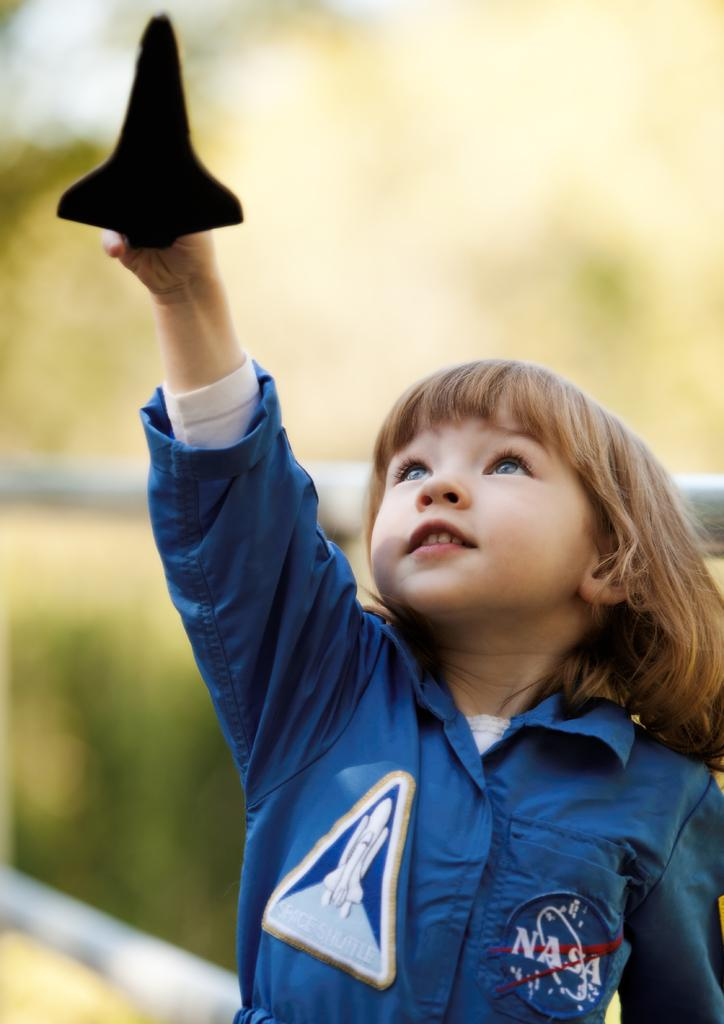<image>
Render a clear and concise summary of the photo. boy wearing blue NASA jumpsuit playing with a toy shuttle 